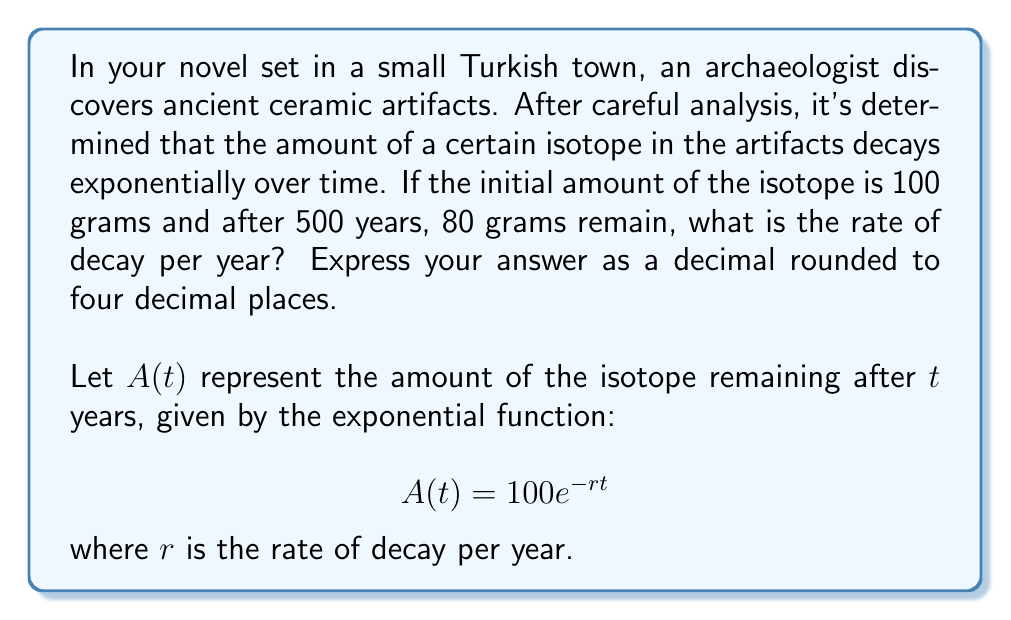Solve this math problem. To solve this problem, we'll use the exponential decay formula and the given information:

1) The general form of the exponential decay function is:
   $$A(t) = A_0e^{-rt}$$
   where $A_0$ is the initial amount, $r$ is the rate of decay, and $t$ is the time.

2) We know:
   - Initial amount $A_0 = 100$ grams
   - After 500 years, $A(500) = 80$ grams
   - Time $t = 500$ years

3) Substituting these values into the equation:
   $$80 = 100e^{-r(500)}$$

4) Divide both sides by 100:
   $$0.8 = e^{-500r}$$

5) Take the natural logarithm of both sides:
   $$\ln(0.8) = -500r$$

6) Solve for $r$:
   $$r = -\frac{\ln(0.8)}{500}$$

7) Calculate the value:
   $$r = -\frac{\ln(0.8)}{500} \approx 0.0004462$$

8) Rounding to four decimal places:
   $$r \approx 0.0004$$
Answer: The rate of decay is approximately 0.0004 per year. 